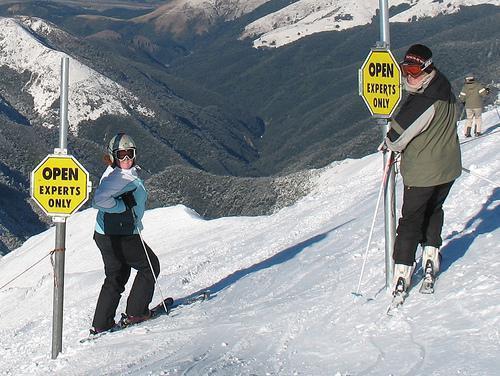How many people are in the picture?
Give a very brief answer. 2. How many umbrellas are there?
Give a very brief answer. 0. 